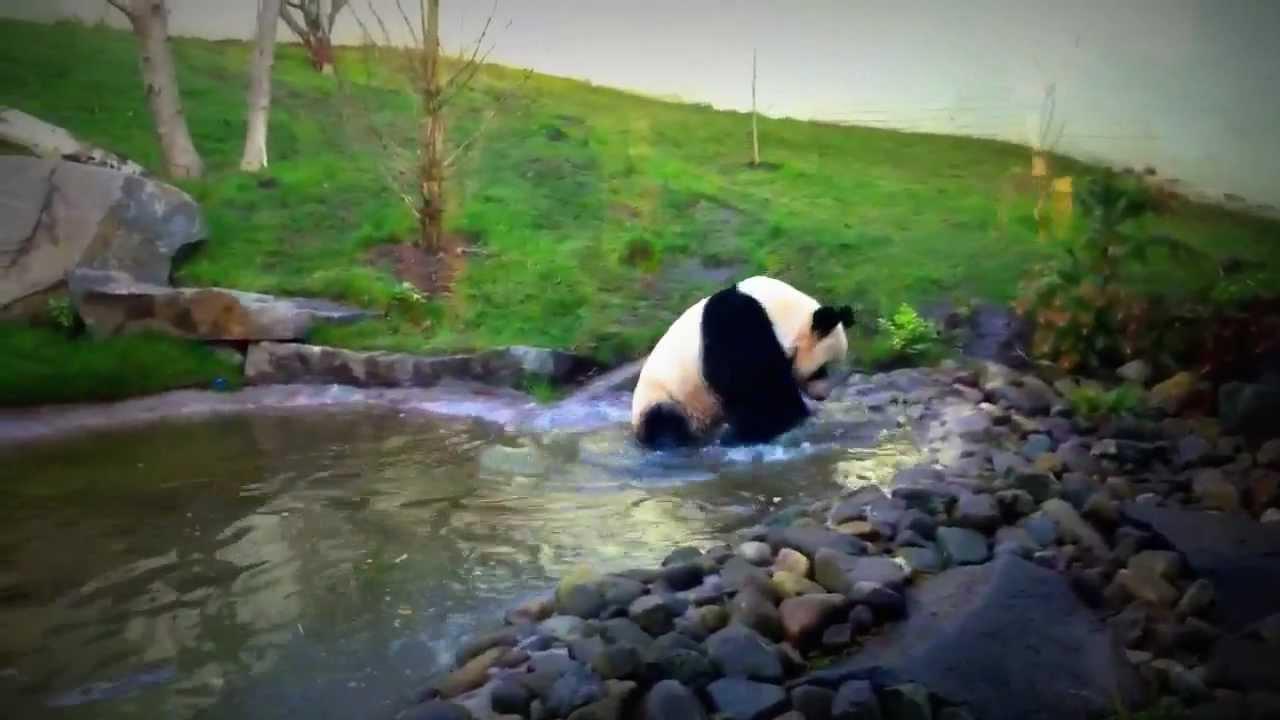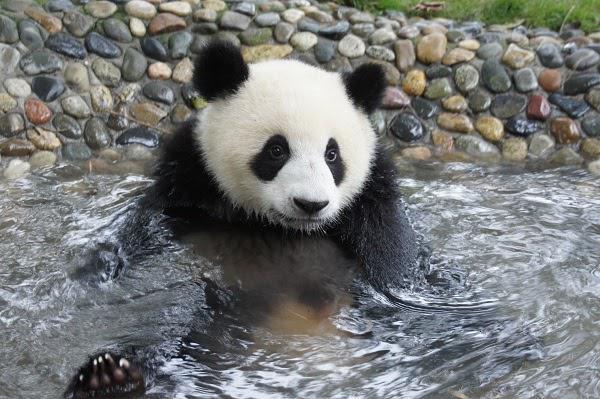The first image is the image on the left, the second image is the image on the right. Given the left and right images, does the statement "One panda is in calm water." hold true? Answer yes or no. Yes. The first image is the image on the left, the second image is the image on the right. Assess this claim about the two images: "At least one image shows a panda in water near a rock formation.". Correct or not? Answer yes or no. Yes. 